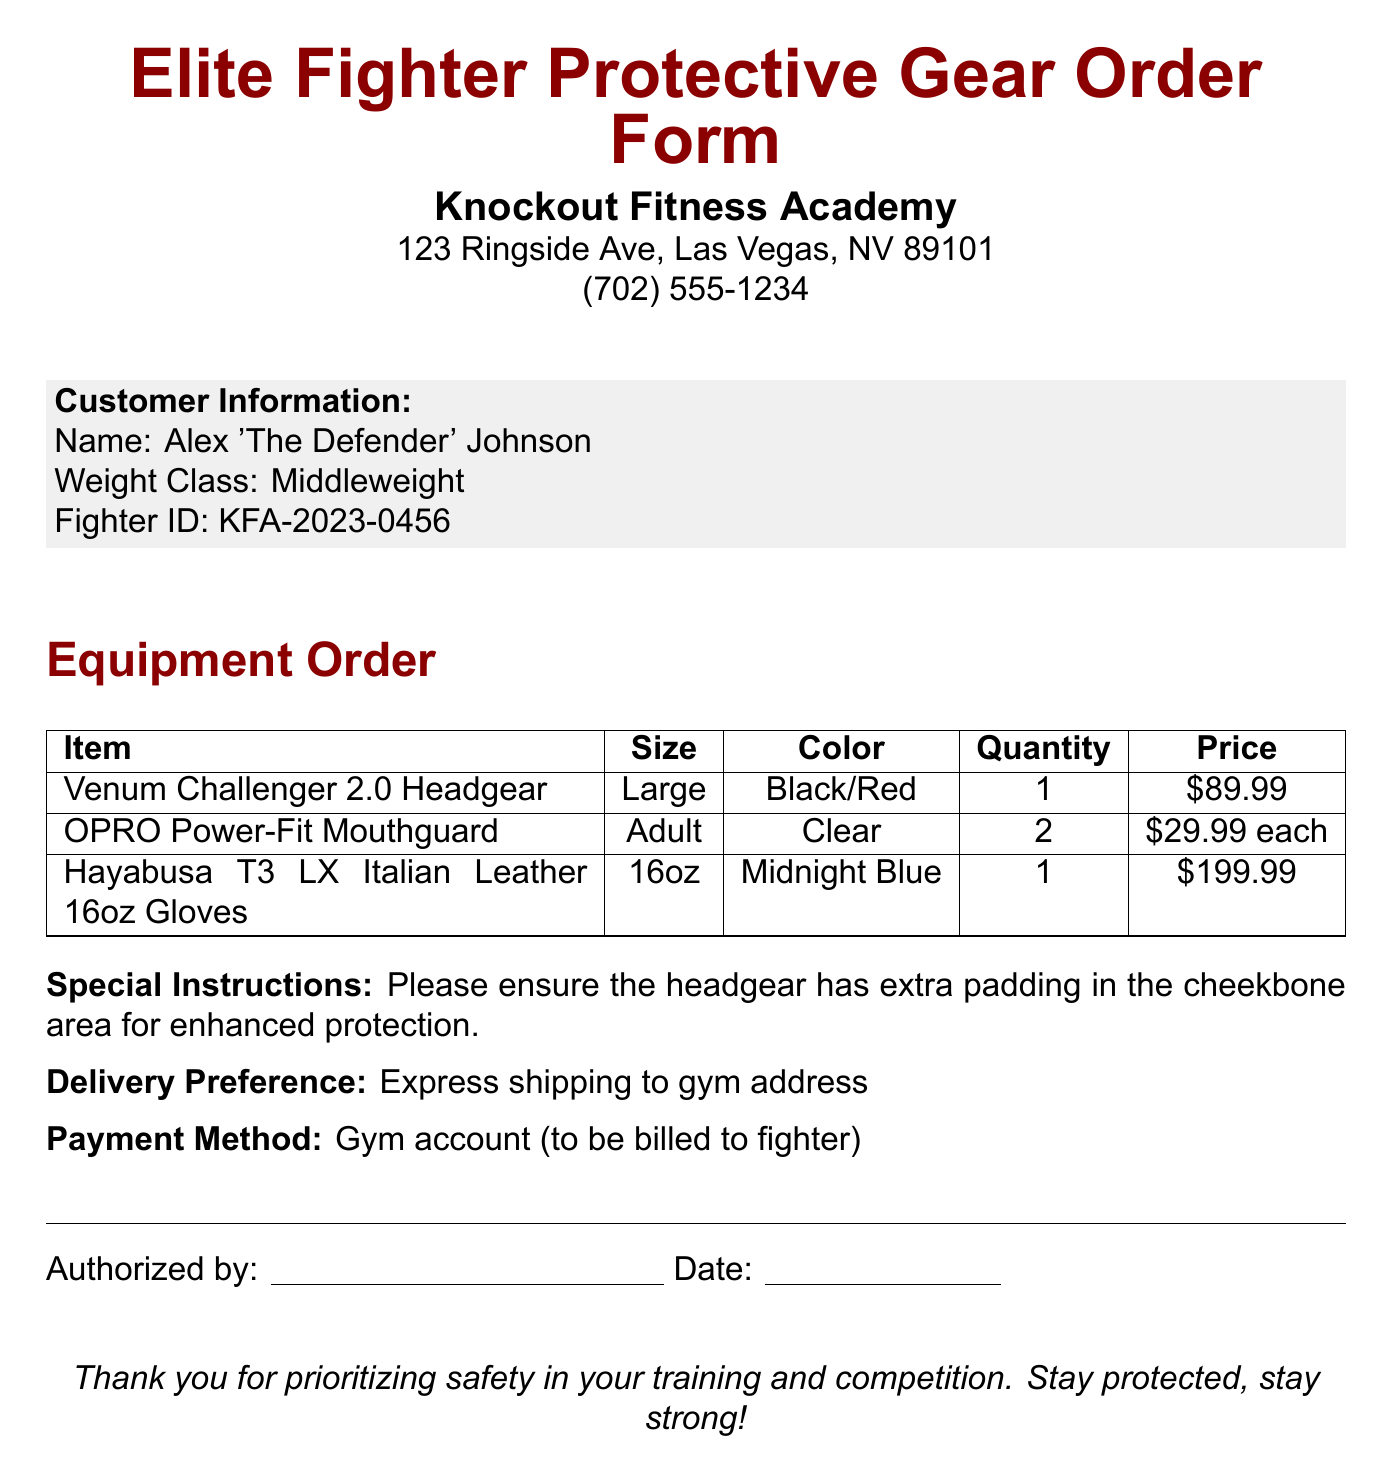What is the name of the fighter? The name of the fighter is found in the customer information section of the document.
Answer: Alex 'The Defender' Johnson What is the price of the Venum Challenger 2.0 Headgear? The price is listed in the equipment order table alongside the item name.
Answer: $89.99 How many OPRO Power-Fit Mouthguards are ordered? The quantity for this item is mentioned in the table under the quantity column.
Answer: 2 What special instruction is given for the headgear? The special instruction provides specifics on what is needed for the headgear, found right before the delivery preference.
Answer: Extra padding in the cheekbone area for enhanced protection What delivery preference is specified? The delivery preference indicates how the order should be shipped, located under the special instructions section.
Answer: Express shipping to gym address What is the weight class of the fighter? The weight class is categorized in the customer information section.
Answer: Middleweight What item includes adult size and clear color? The item description must match the specified size and color in the order table.
Answer: OPRO Power-Fit Mouthguard What payment method is used for this order? The payment method indicates how the order will be paid, detailed in a separate section.
Answer: Gym account (to be billed to fighter) 